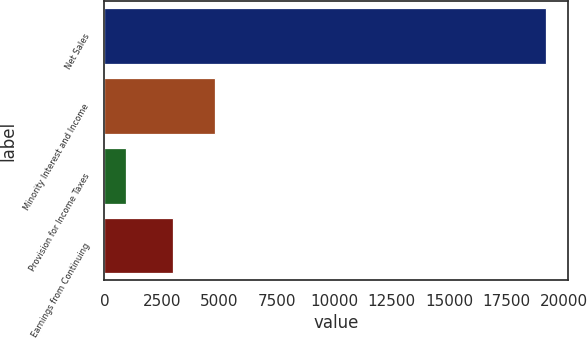<chart> <loc_0><loc_0><loc_500><loc_500><bar_chart><fcel>Net Sales<fcel>Minority Interest and Income<fcel>Provision for Income Taxes<fcel>Earnings from Continuing<nl><fcel>19207<fcel>4819.5<fcel>932<fcel>2992<nl></chart> 